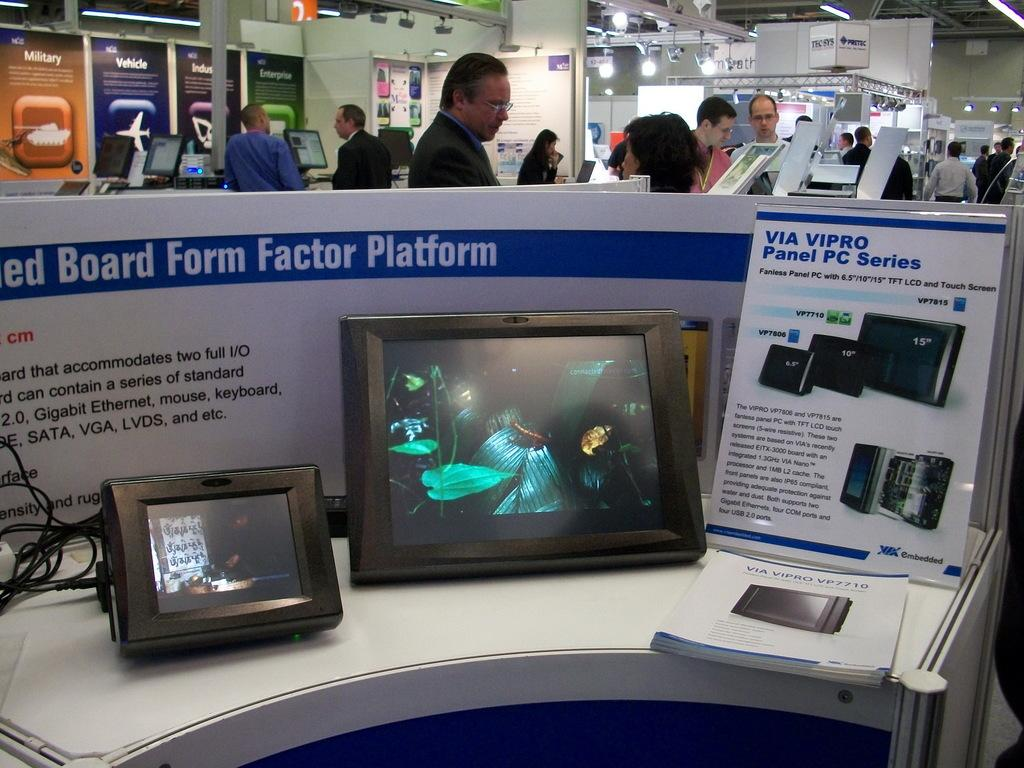Provide a one-sentence caption for the provided image. Two panel PCs displaying movies with an information guide about the PCs beside them. 